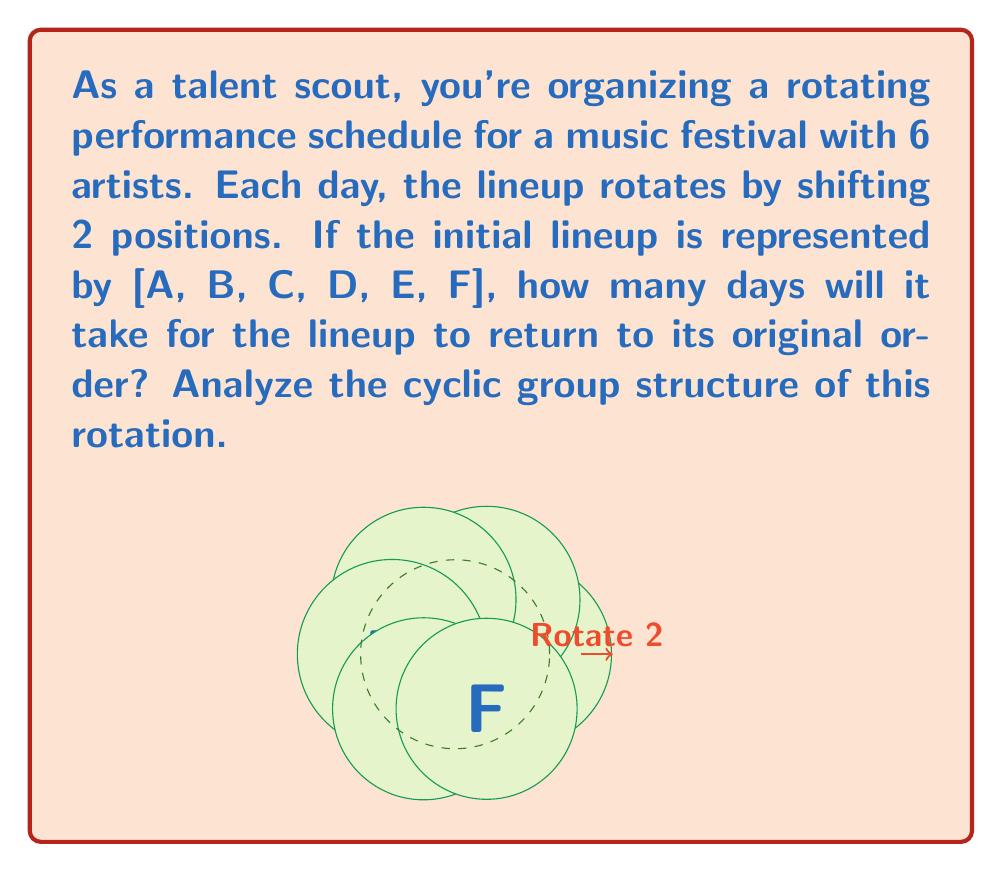Provide a solution to this math problem. Let's approach this step-by-step:

1) First, we need to understand the group structure. The rotation operation forms a cyclic group, where each application of the rotation is an element of the group.

2) Let's denote the rotation operation as $r$. The initial state is the identity element $e$, and each application of $r$ rotates the lineup by 2 positions.

3) We need to find the order of the group, which is the smallest positive integer $n$ such that $r^n = e$.

4) Let's see what happens with each application of $r$:
   $r^1: [C, D, E, F, A, B]$
   $r^2: [E, F, A, B, C, D]$
   $r^3: [A, B, C, D, E, F]$

5) We see that $r^3 = e$, so the order of the group is 3.

6) Mathematically, we can arrive at this result by considering that we have 6 positions, and each rotation shifts by 2 positions. The number of rotations needed to return to the original state is:

   $$n = \frac{lcm(6,2)}{2} = \frac{6}{2} = 3$$

   Where $lcm$ is the least common multiple.

7) This cyclic group is isomorphic to $\mathbb{Z}_3$, the integers modulo 3.

Therefore, it will take 3 days for the lineup to return to its original order.
Answer: 3 days 